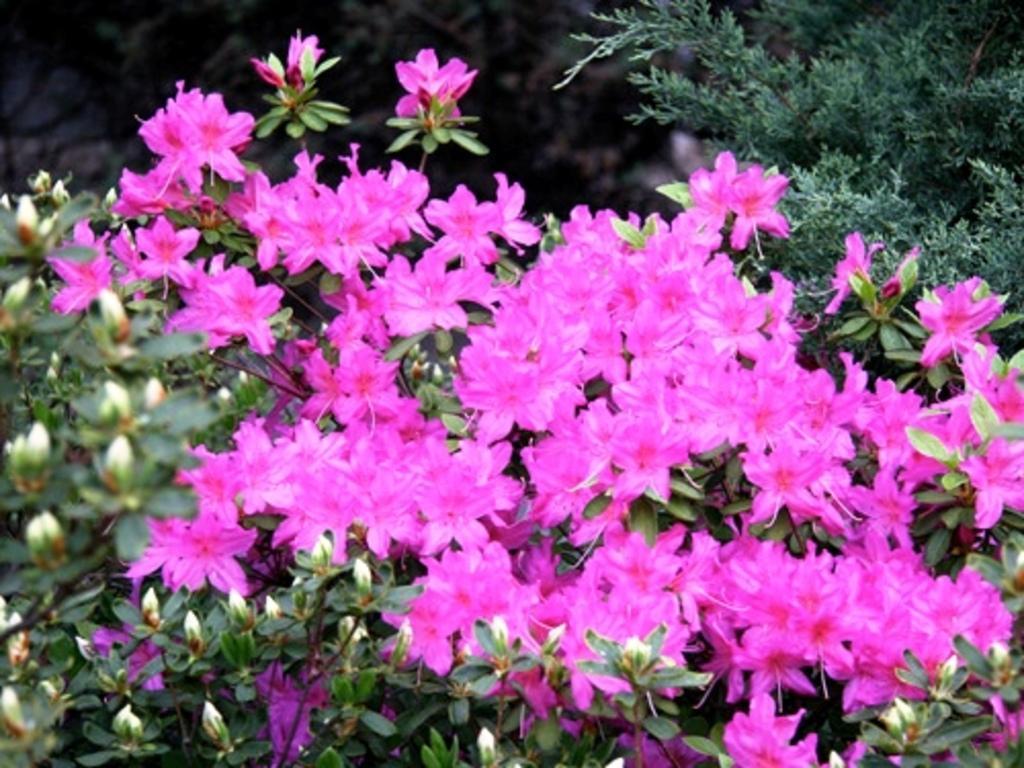In one or two sentences, can you explain what this image depicts? Here we can see pink flowers, buds and leaves. Background it is blur. 